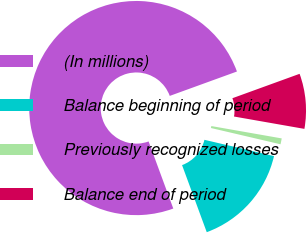<chart> <loc_0><loc_0><loc_500><loc_500><pie_chart><fcel>(In millions)<fcel>Balance beginning of period<fcel>Previously recognized losses<fcel>Balance end of period<nl><fcel>75.07%<fcel>15.73%<fcel>0.89%<fcel>8.31%<nl></chart> 